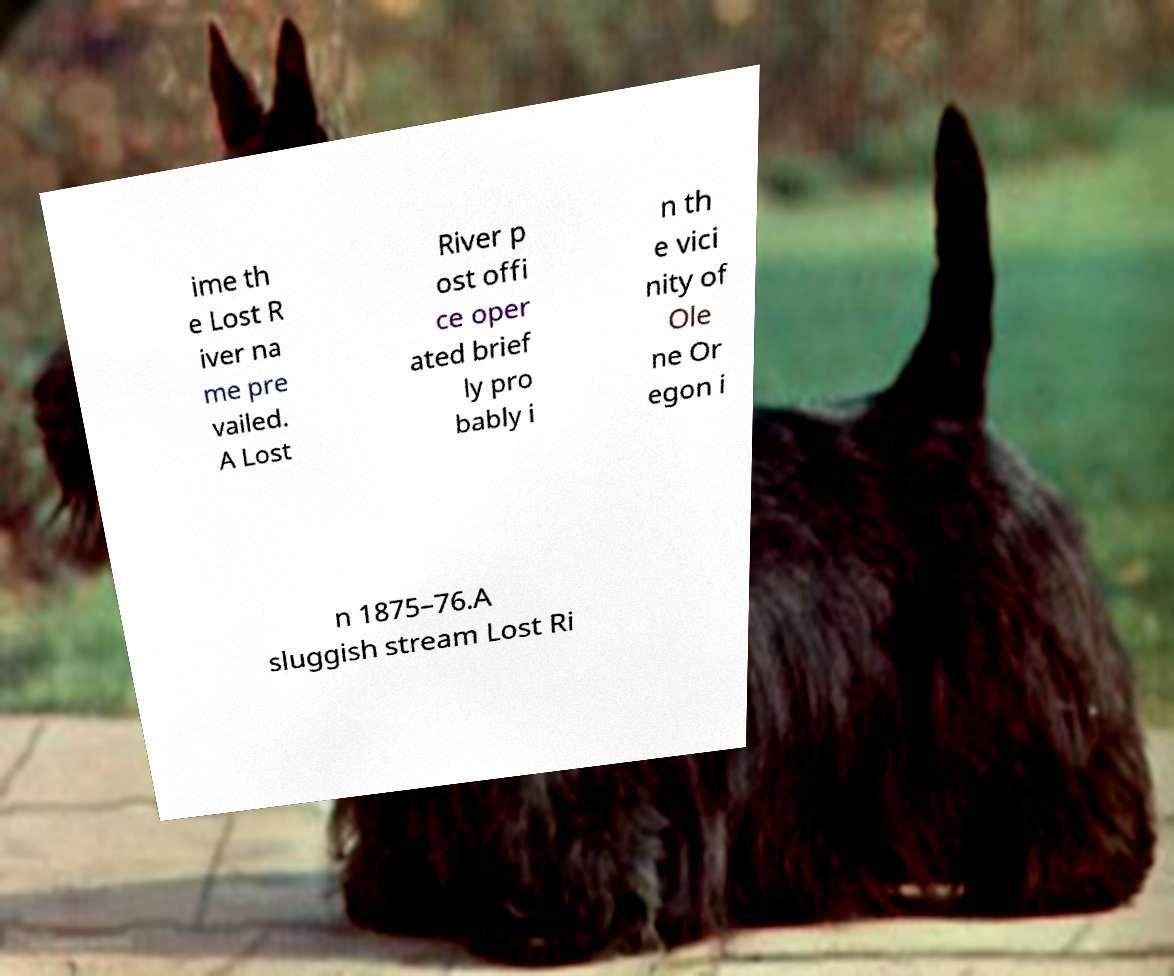Please identify and transcribe the text found in this image. ime th e Lost R iver na me pre vailed. A Lost River p ost offi ce oper ated brief ly pro bably i n th e vici nity of Ole ne Or egon i n 1875–76.A sluggish stream Lost Ri 